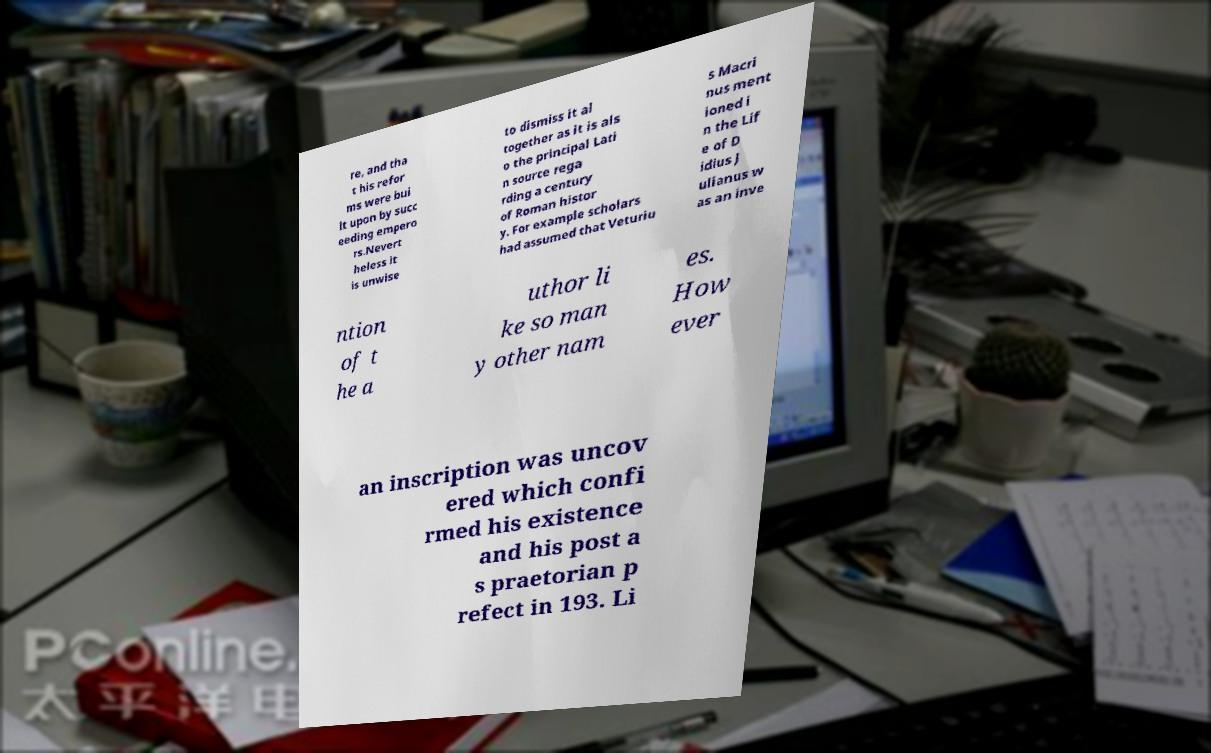For documentation purposes, I need the text within this image transcribed. Could you provide that? re, and tha t his refor ms were bui lt upon by succ eeding empero rs.Nevert heless it is unwise to dismiss it al together as it is als o the principal Lati n source rega rding a century of Roman histor y. For example scholars had assumed that Veturiu s Macri nus ment ioned i n the Lif e of D idius J ulianus w as an inve ntion of t he a uthor li ke so man y other nam es. How ever an inscription was uncov ered which confi rmed his existence and his post a s praetorian p refect in 193. Li 